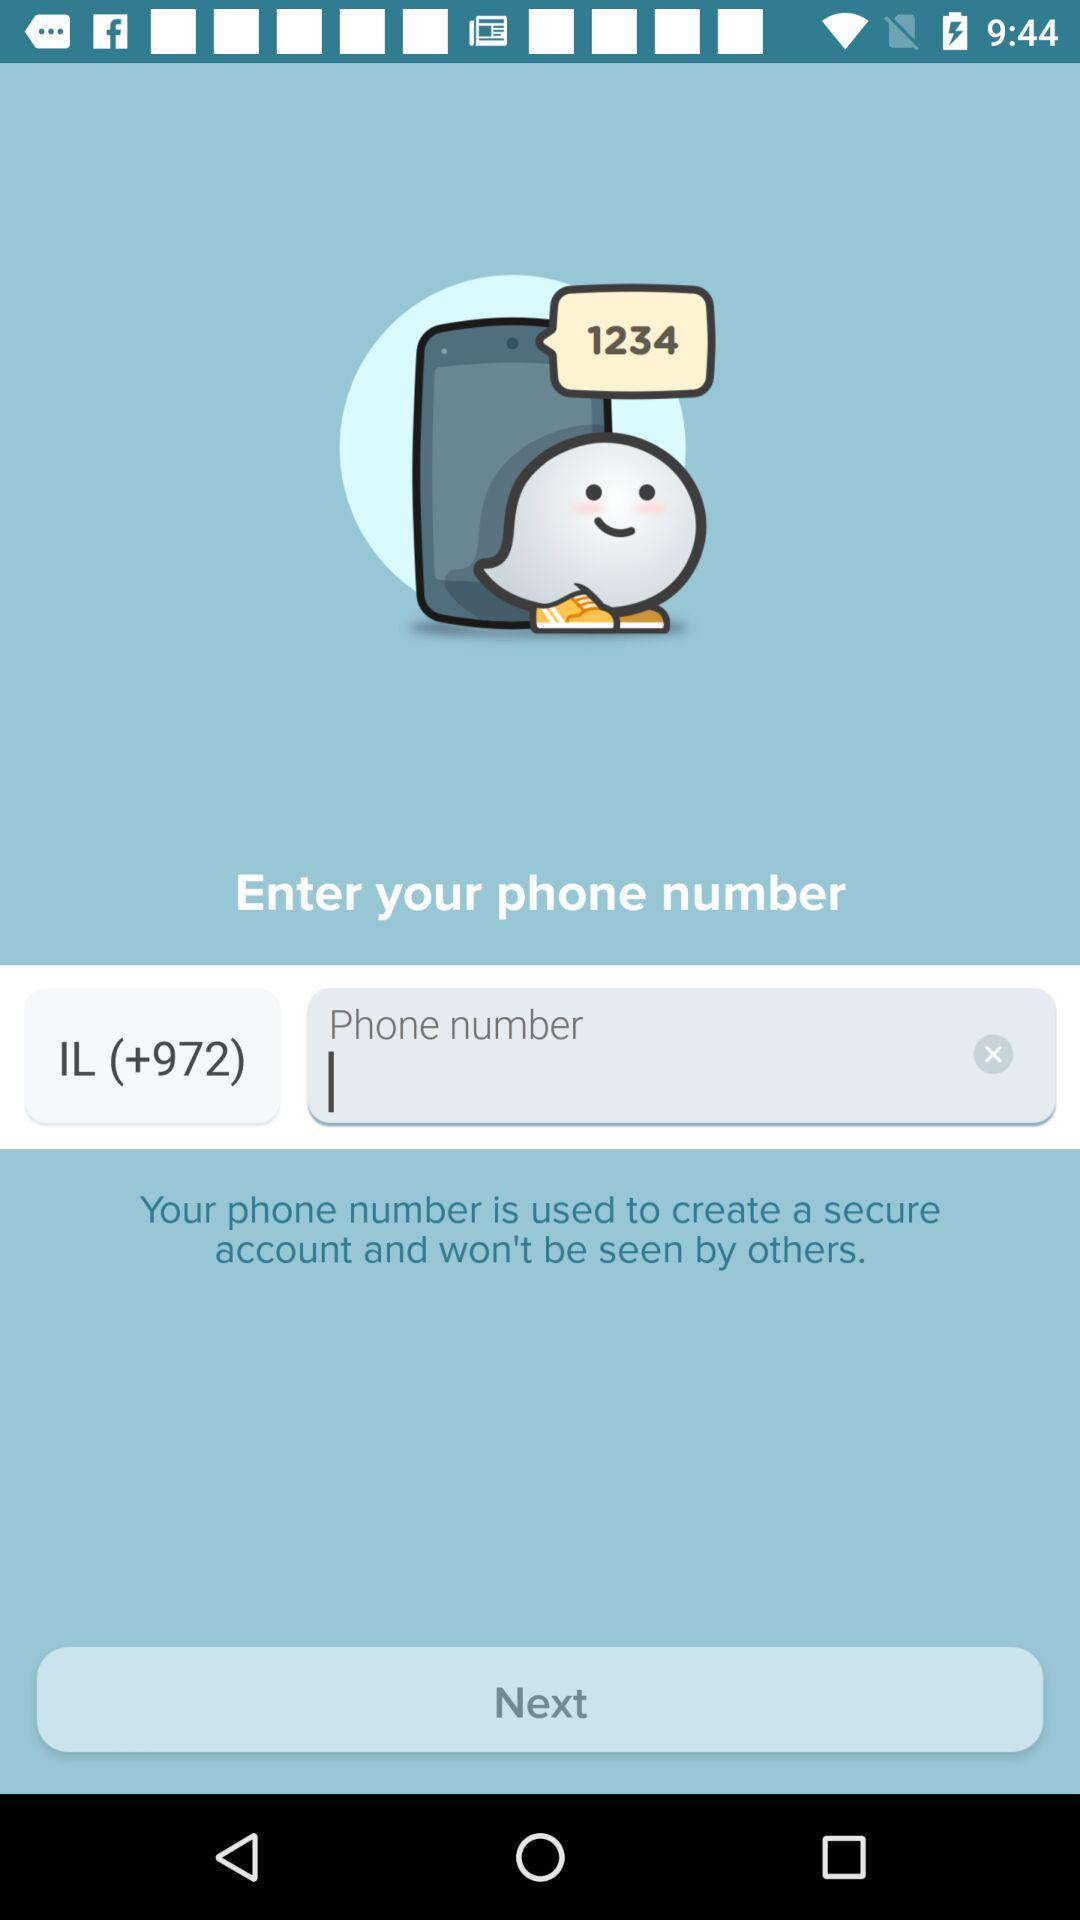Which phone number is entered?
When the provided information is insufficient, respond with <no answer>. <no answer> 